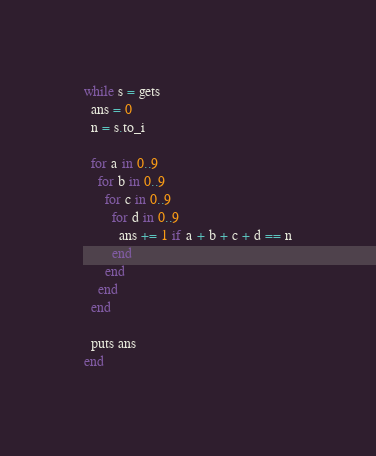<code> <loc_0><loc_0><loc_500><loc_500><_Ruby_>while s = gets
  ans = 0
  n = s.to_i

  for a in 0..9
    for b in 0..9
      for c in 0..9
        for d in 0..9
          ans += 1 if a + b + c + d == n
        end
      end
    end
  end

  puts ans
end</code> 